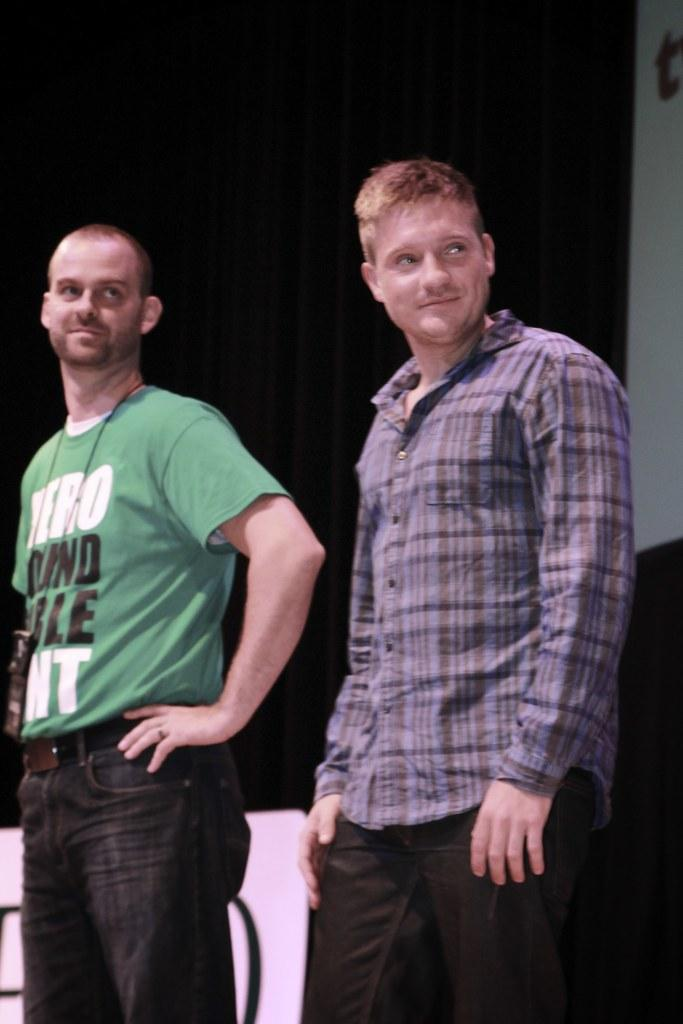What is the main subject of the image? The main subject of the image is the persons standing in the center. Where are the persons standing? The persons are standing on the floor. What can be seen in the background of the image? There is an advertisement visible in the background. What type of plants can be seen growing on the road in the image? There is no road or plants present in the image; it features persons standing on the floor with an advertisement in the background. 